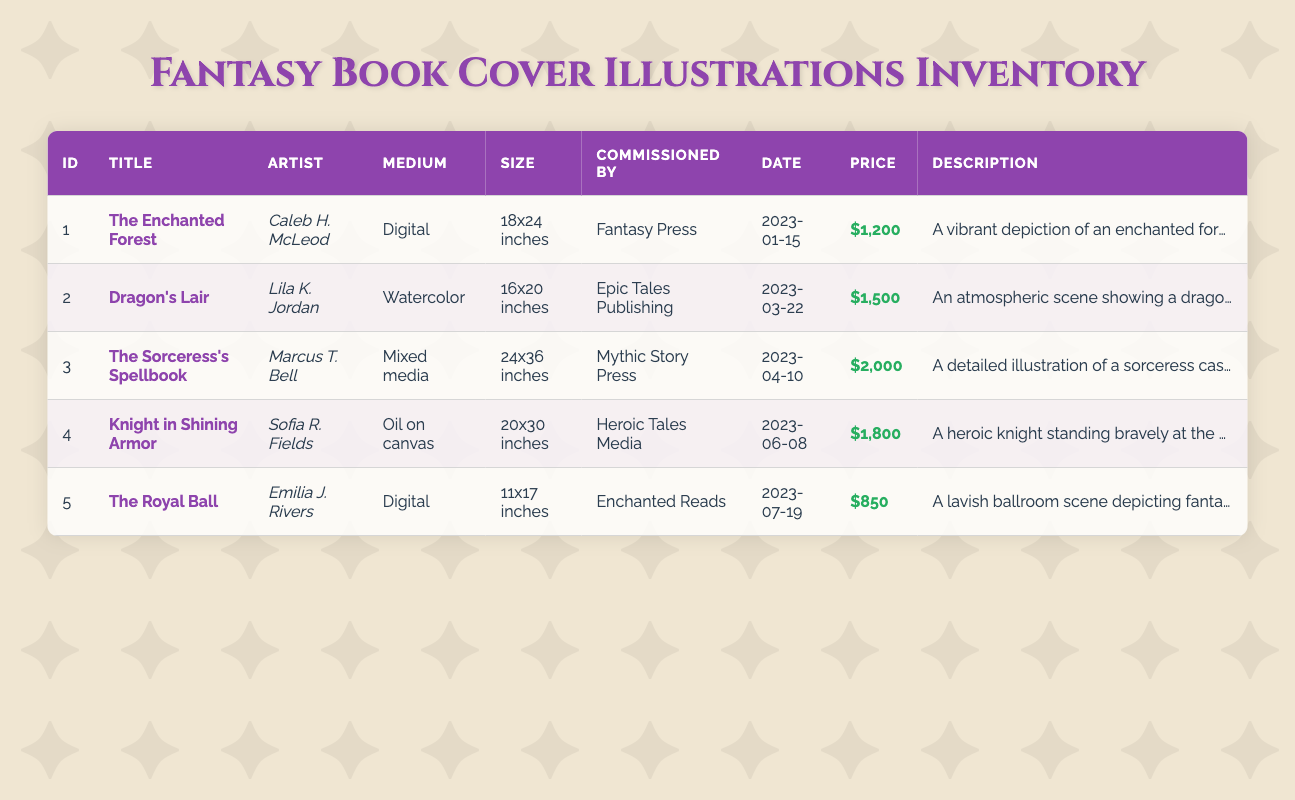What is the title of the illustration commissioned by Fantasy Press? Find the "commissioned_by" column and look for Fantasy Press. The corresponding "title" is The Enchanted Forest.
Answer: The Enchanted Forest How many illustrations are medium digital? Count the rows where the "medium" equals Digital. The illustrations with Digital medium are The Enchanted Forest and The Royal Ball, making it a total of 2.
Answer: 2 Who is the artist for the most expensive illustration? Check the "price" column to identify the highest value, which is $2,000. The corresponding illustration is The Sorceress's Spellbook, created by Marcus T. Bell.
Answer: Marcus T. Bell What is the average price of all illustrations? Sum the prices: 1200 + 1500 + 2000 + 1800 + 850 = 6550. There are 5 illustrations, so the average price is 6550 / 5 = 1310.
Answer: 1310 Is there an illustration depicting a knight? Check the "description" column for any mention of a knight. Yes, Knight in Shining Armor clearly depicts a heroic knight.
Answer: Yes What is the cheapest illustration and who is the artist? Look at the "price" column to find the lowest value, which is $850 corresponding to The Royal Ball, created by Emilia J. Rivers.
Answer: Emilia J. Rivers How many illustrations were commissioned after April 2023? Look at the "commission_date" for dates after April 10, 2023. The illustrations commissioned after that date are Knight in Shining Armor and The Royal Ball, totaling 2.
Answer: 2 What is the most common genre of illustrations in this inventory? The genre is the same for all entries, which is Fantasy. Hence, Fantasy is the most common genre.
Answer: Fantasy Which commissioned illustration has the largest size, and who was it commissioned by? Check the "size" column, where The Sorceress's Spellbook with size 24x36 inches is the largest. It was commissioned by Mythic Story Press.
Answer: Mythic Story Press 